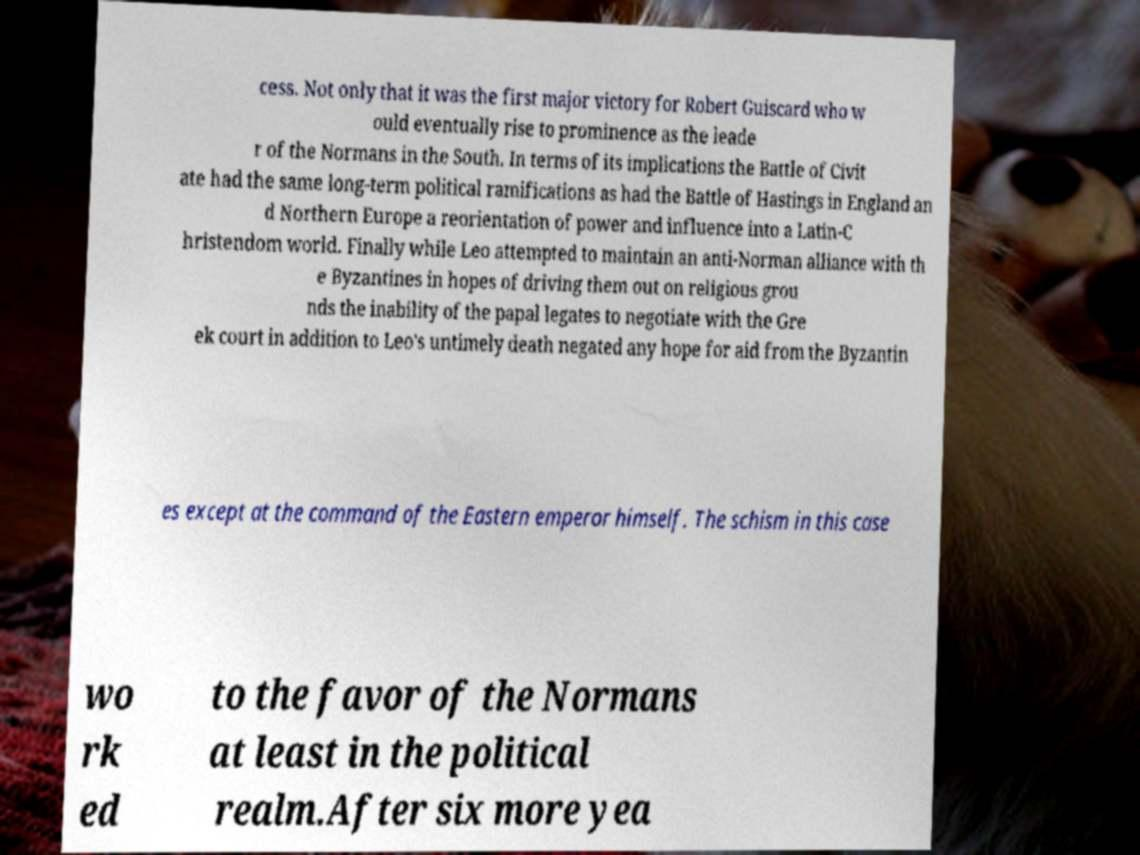There's text embedded in this image that I need extracted. Can you transcribe it verbatim? cess. Not only that it was the first major victory for Robert Guiscard who w ould eventually rise to prominence as the leade r of the Normans in the South. In terms of its implications the Battle of Civit ate had the same long-term political ramifications as had the Battle of Hastings in England an d Northern Europe a reorientation of power and influence into a Latin-C hristendom world. Finally while Leo attempted to maintain an anti-Norman alliance with th e Byzantines in hopes of driving them out on religious grou nds the inability of the papal legates to negotiate with the Gre ek court in addition to Leo's untimely death negated any hope for aid from the Byzantin es except at the command of the Eastern emperor himself. The schism in this case wo rk ed to the favor of the Normans at least in the political realm.After six more yea 